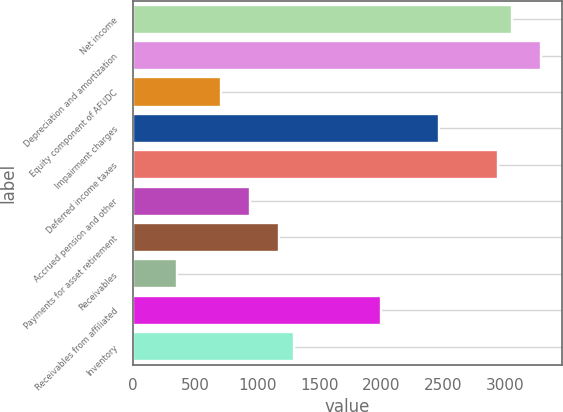<chart> <loc_0><loc_0><loc_500><loc_500><bar_chart><fcel>Net income<fcel>Depreciation and amortization<fcel>Equity component of AFUDC<fcel>Impairment charges<fcel>Deferred income taxes<fcel>Accrued pension and other<fcel>Payments for asset retirement<fcel>Receivables<fcel>Receivables from affiliated<fcel>Inventory<nl><fcel>3052.8<fcel>3287.4<fcel>706.8<fcel>2466.3<fcel>2935.5<fcel>941.4<fcel>1176<fcel>354.9<fcel>1997.1<fcel>1293.3<nl></chart> 